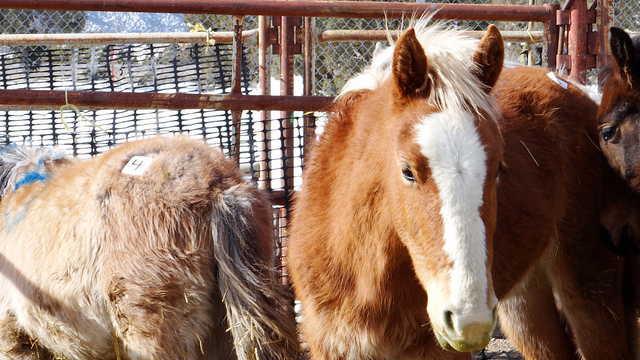Please identify all text content in this image. 4 5 